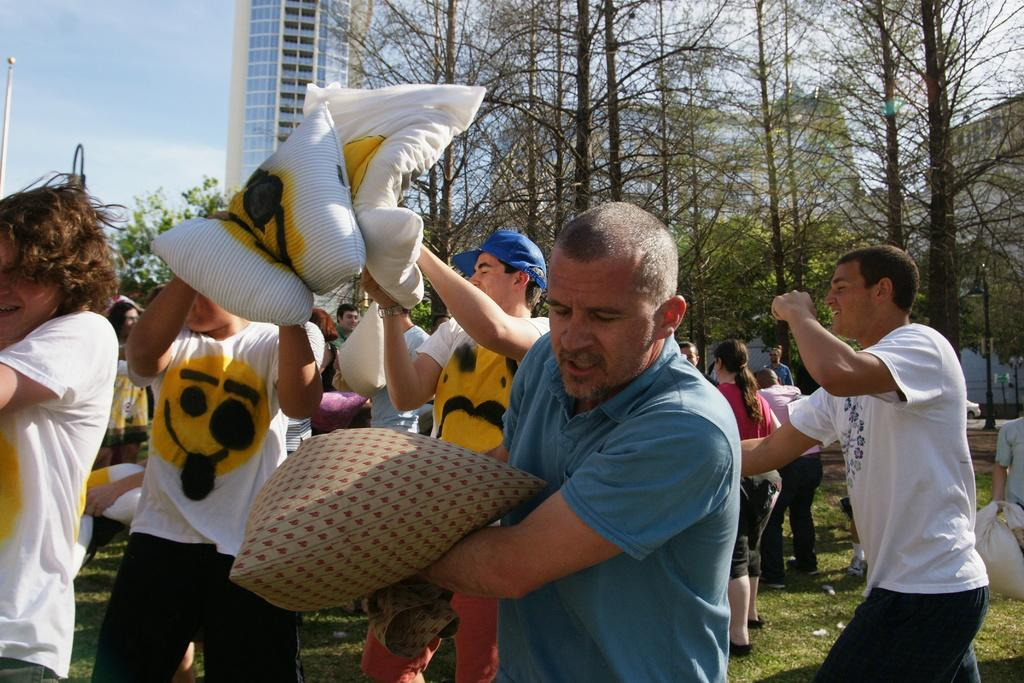What are the people in the image doing? The people in the image are standing on the ground. What objects are the people holding? The people are holding pillows. What can be seen in the background of the image? There are trees and a building visible in the background. What type of clouds can be seen in the image? There are no clouds visible in the image; only trees and a building can be seen in the background. 